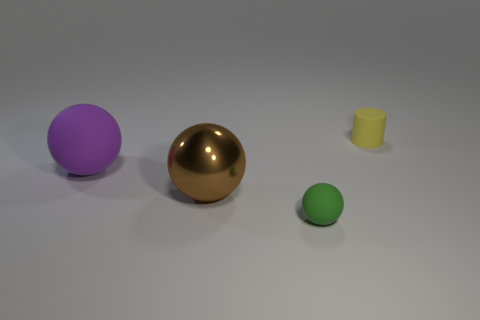Add 2 big purple matte objects. How many objects exist? 6 Subtract all balls. How many objects are left? 1 Subtract 0 green cylinders. How many objects are left? 4 Subtract all tiny green matte balls. Subtract all big brown matte things. How many objects are left? 3 Add 1 small matte balls. How many small matte balls are left? 2 Add 4 tiny yellow rubber objects. How many tiny yellow rubber objects exist? 5 